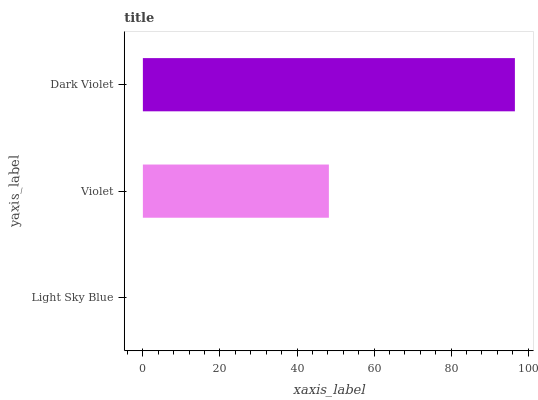Is Light Sky Blue the minimum?
Answer yes or no. Yes. Is Dark Violet the maximum?
Answer yes or no. Yes. Is Violet the minimum?
Answer yes or no. No. Is Violet the maximum?
Answer yes or no. No. Is Violet greater than Light Sky Blue?
Answer yes or no. Yes. Is Light Sky Blue less than Violet?
Answer yes or no. Yes. Is Light Sky Blue greater than Violet?
Answer yes or no. No. Is Violet less than Light Sky Blue?
Answer yes or no. No. Is Violet the high median?
Answer yes or no. Yes. Is Violet the low median?
Answer yes or no. Yes. Is Light Sky Blue the high median?
Answer yes or no. No. Is Dark Violet the low median?
Answer yes or no. No. 